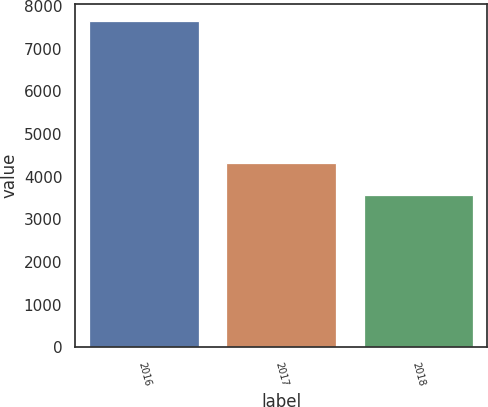Convert chart to OTSL. <chart><loc_0><loc_0><loc_500><loc_500><bar_chart><fcel>2016<fcel>2017<fcel>2018<nl><fcel>7660<fcel>4317<fcel>3568<nl></chart> 